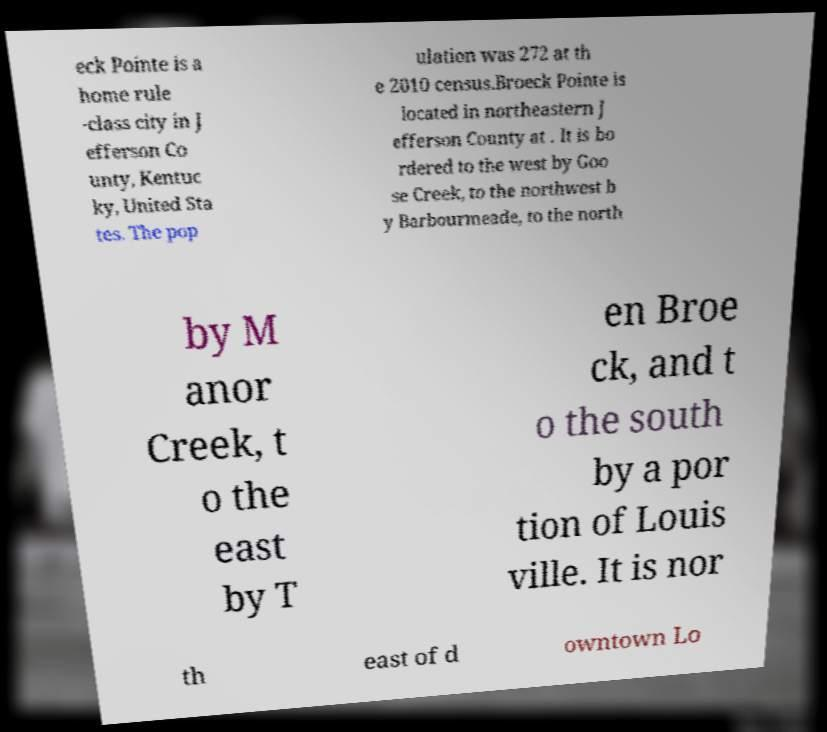Can you read and provide the text displayed in the image?This photo seems to have some interesting text. Can you extract and type it out for me? eck Pointe is a home rule -class city in J efferson Co unty, Kentuc ky, United Sta tes. The pop ulation was 272 at th e 2010 census.Broeck Pointe is located in northeastern J efferson County at . It is bo rdered to the west by Goo se Creek, to the northwest b y Barbourmeade, to the north by M anor Creek, t o the east by T en Broe ck, and t o the south by a por tion of Louis ville. It is nor th east of d owntown Lo 